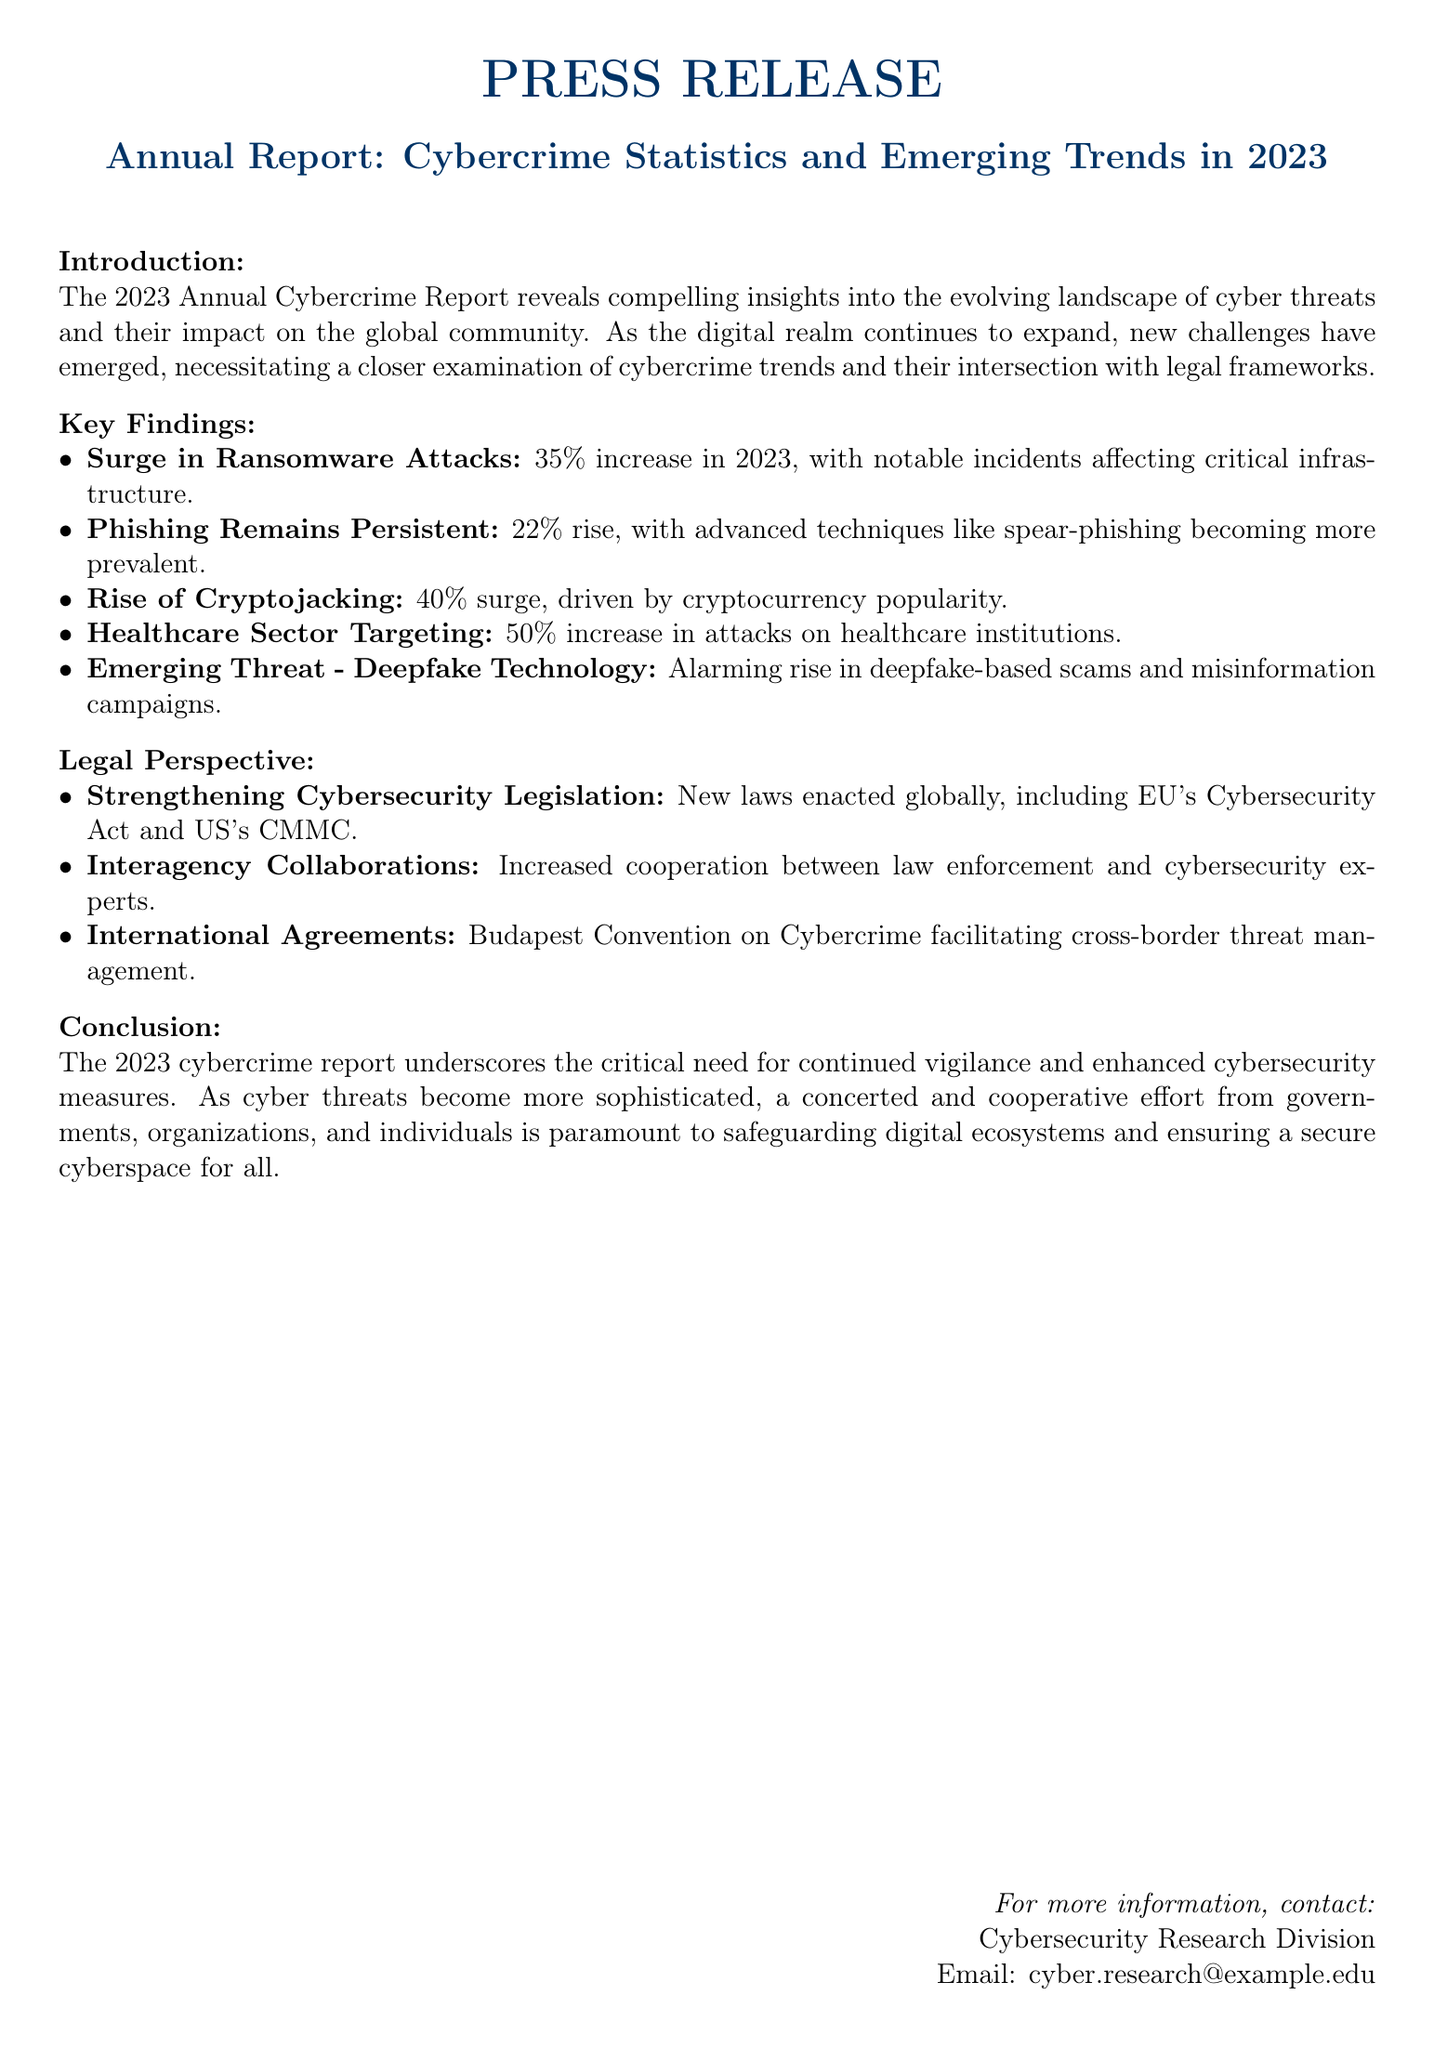What was the percentage increase in ransomware attacks in 2023? The report states that there was a 35% increase in ransomware attacks in 2023.
Answer: 35% What new legislation was mentioned in the report? The report highlights the new EU's Cybersecurity Act and US's CMMC as examples of new laws enacted globally.
Answer: EU's Cybersecurity Act and US's CMMC What sector saw a 50% increase in cyberattacks? The report indicates that there was a 50% increase in attacks on healthcare institutions.
Answer: Healthcare institutions Which type of cybercrime surged by 40%? The rise of cryptojacking, driven by cryptocurrency popularity, saw a 40% surge according to the report.
Answer: Cryptojacking What emerging threat is specifically mentioned in the report? The report discusses the alarming rise of deepfake technology in terms of scams and misinformation campaigns.
Answer: Deepfake technology How did phishing incidents change in 2023? The report mentions that phishing incidents saw a 22% rise in 2023.
Answer: 22% What is emphasized as necessary to combat cybercrime? The conclusion of the report underscores the critical need for continued vigilance and enhanced cybersecurity measures.
Answer: Continued vigilance and enhanced cybersecurity measures Which international agreement is facilitating cross-border threat management? The Budapest Convention on Cybercrime is mentioned as facilitating cross-border threat management.
Answer: Budapest Convention on Cybercrime What type of cooperation has increased between law enforcement and cybersecurity experts? The report notes an increase in interagency collaborations between these two parties.
Answer: Interagency collaborations 